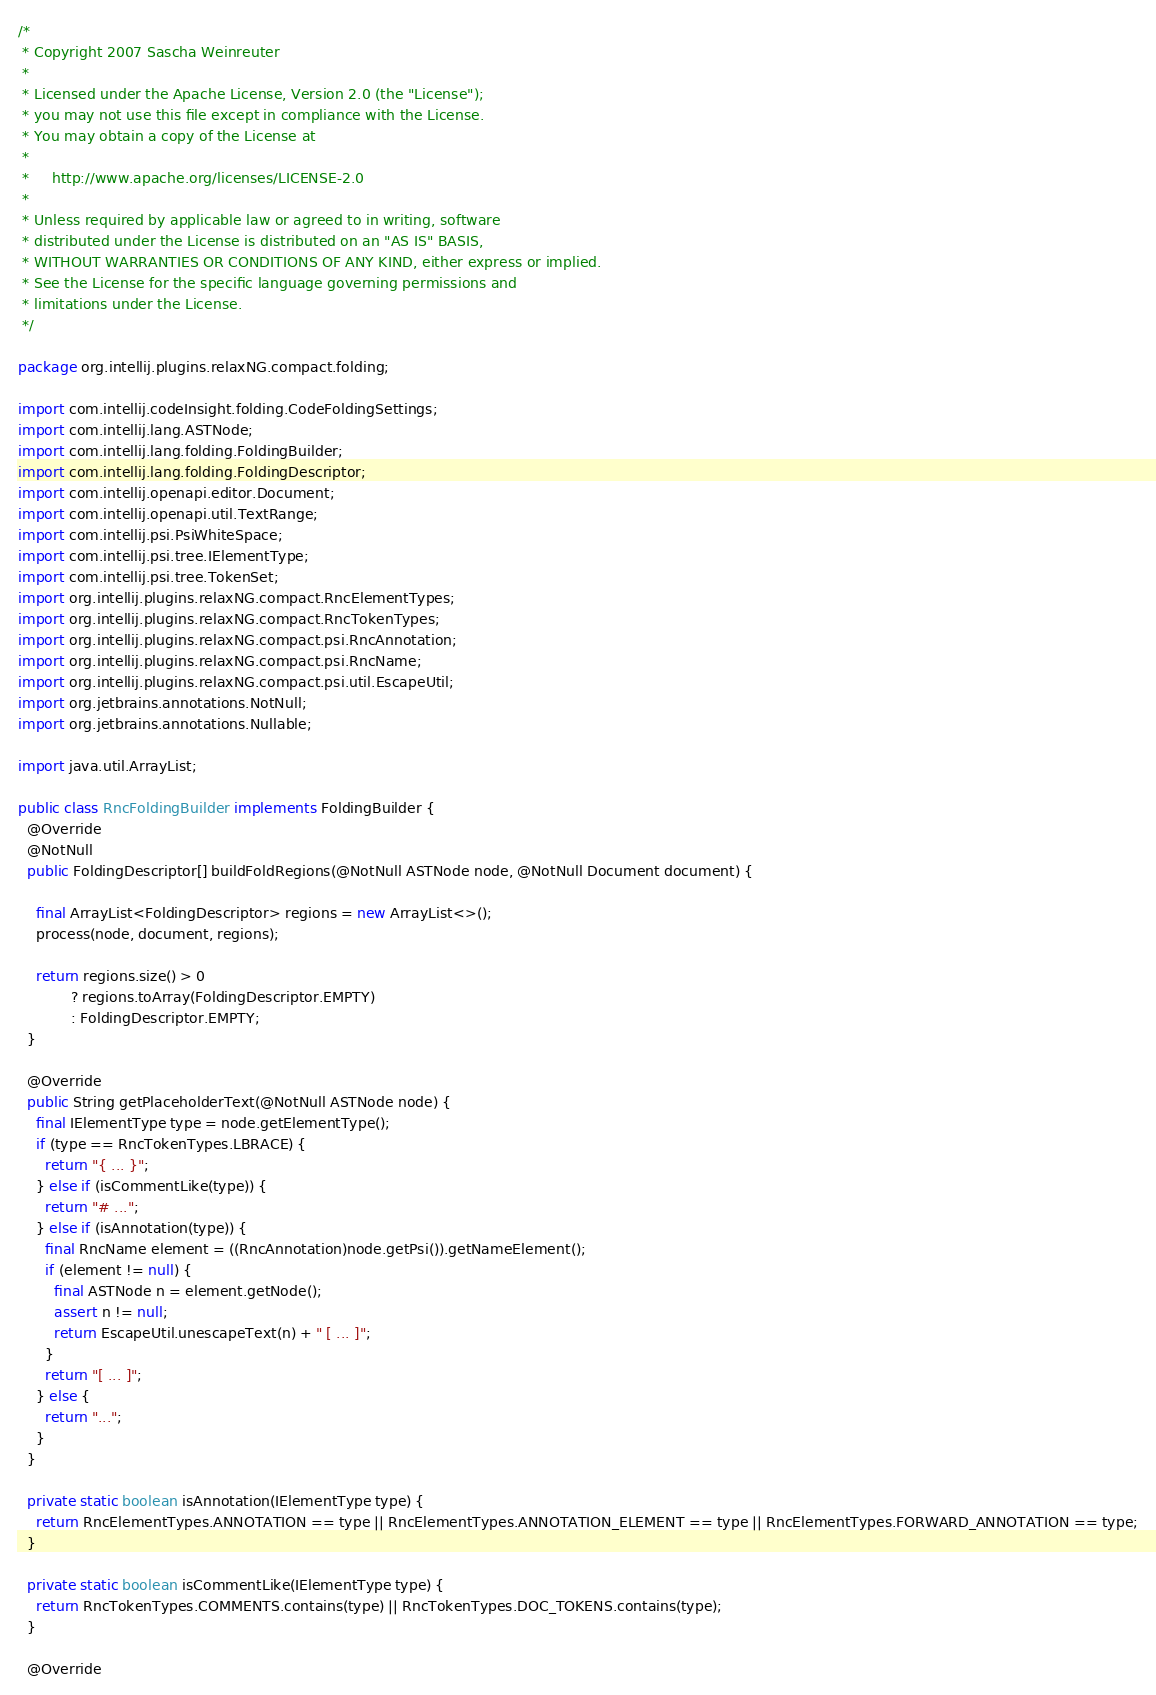<code> <loc_0><loc_0><loc_500><loc_500><_Java_>/*
 * Copyright 2007 Sascha Weinreuter
 *
 * Licensed under the Apache License, Version 2.0 (the "License");
 * you may not use this file except in compliance with the License.
 * You may obtain a copy of the License at
 *
 *     http://www.apache.org/licenses/LICENSE-2.0
 *
 * Unless required by applicable law or agreed to in writing, software
 * distributed under the License is distributed on an "AS IS" BASIS,
 * WITHOUT WARRANTIES OR CONDITIONS OF ANY KIND, either express or implied.
 * See the License for the specific language governing permissions and
 * limitations under the License.
 */

package org.intellij.plugins.relaxNG.compact.folding;

import com.intellij.codeInsight.folding.CodeFoldingSettings;
import com.intellij.lang.ASTNode;
import com.intellij.lang.folding.FoldingBuilder;
import com.intellij.lang.folding.FoldingDescriptor;
import com.intellij.openapi.editor.Document;
import com.intellij.openapi.util.TextRange;
import com.intellij.psi.PsiWhiteSpace;
import com.intellij.psi.tree.IElementType;
import com.intellij.psi.tree.TokenSet;
import org.intellij.plugins.relaxNG.compact.RncElementTypes;
import org.intellij.plugins.relaxNG.compact.RncTokenTypes;
import org.intellij.plugins.relaxNG.compact.psi.RncAnnotation;
import org.intellij.plugins.relaxNG.compact.psi.RncName;
import org.intellij.plugins.relaxNG.compact.psi.util.EscapeUtil;
import org.jetbrains.annotations.NotNull;
import org.jetbrains.annotations.Nullable;

import java.util.ArrayList;

public class RncFoldingBuilder implements FoldingBuilder {
  @Override
  @NotNull
  public FoldingDescriptor[] buildFoldRegions(@NotNull ASTNode node, @NotNull Document document) {

    final ArrayList<FoldingDescriptor> regions = new ArrayList<>();
    process(node, document, regions);

    return regions.size() > 0
            ? regions.toArray(FoldingDescriptor.EMPTY)
            : FoldingDescriptor.EMPTY;
  }

  @Override
  public String getPlaceholderText(@NotNull ASTNode node) {
    final IElementType type = node.getElementType();
    if (type == RncTokenTypes.LBRACE) {
      return "{ ... }";
    } else if (isCommentLike(type)) {
      return "# ...";
    } else if (isAnnotation(type)) {
      final RncName element = ((RncAnnotation)node.getPsi()).getNameElement();
      if (element != null) {
        final ASTNode n = element.getNode();
        assert n != null;
        return EscapeUtil.unescapeText(n) + " [ ... ]";
      }
      return "[ ... ]";
    } else {
      return "...";
    }
  }

  private static boolean isAnnotation(IElementType type) {
    return RncElementTypes.ANNOTATION == type || RncElementTypes.ANNOTATION_ELEMENT == type || RncElementTypes.FORWARD_ANNOTATION == type;
  }

  private static boolean isCommentLike(IElementType type) {
    return RncTokenTypes.COMMENTS.contains(type) || RncTokenTypes.DOC_TOKENS.contains(type);
  }

  @Override</code> 